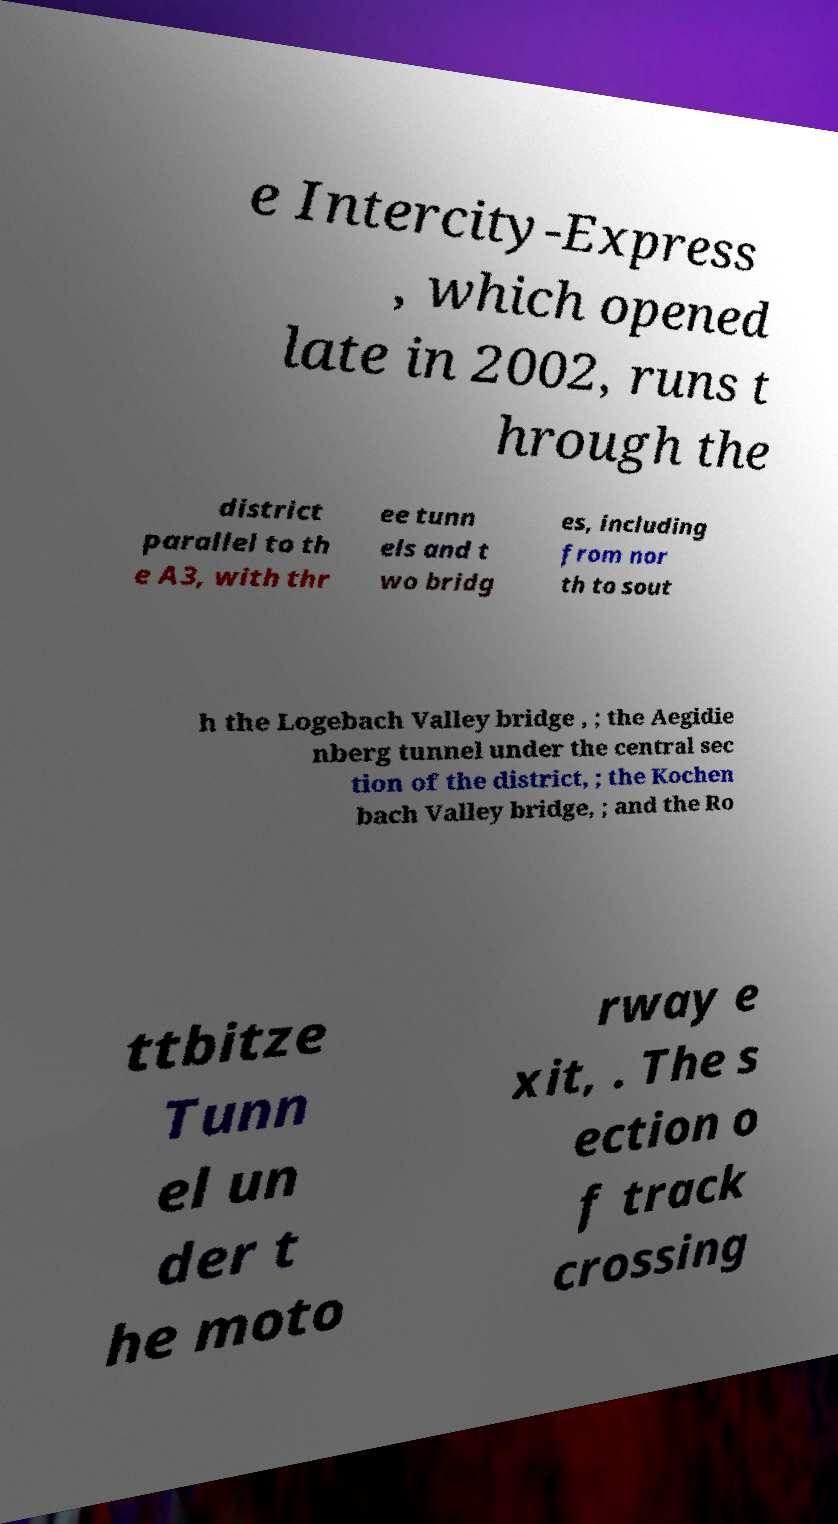Could you extract and type out the text from this image? e Intercity-Express , which opened late in 2002, runs t hrough the district parallel to th e A3, with thr ee tunn els and t wo bridg es, including from nor th to sout h the Logebach Valley bridge , ; the Aegidie nberg tunnel under the central sec tion of the district, ; the Kochen bach Valley bridge, ; and the Ro ttbitze Tunn el un der t he moto rway e xit, . The s ection o f track crossing 